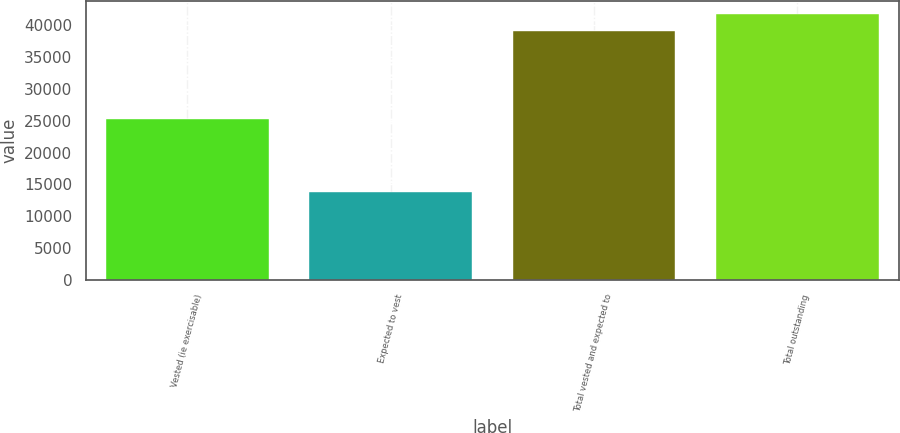Convert chart to OTSL. <chart><loc_0><loc_0><loc_500><loc_500><bar_chart><fcel>Vested (ie exercisable)<fcel>Expected to vest<fcel>Total vested and expected to<fcel>Total outstanding<nl><fcel>25205<fcel>13869<fcel>39074<fcel>41662.8<nl></chart> 